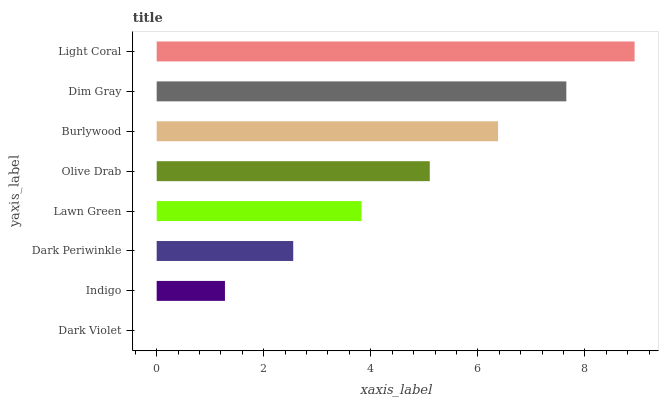Is Dark Violet the minimum?
Answer yes or no. Yes. Is Light Coral the maximum?
Answer yes or no. Yes. Is Indigo the minimum?
Answer yes or no. No. Is Indigo the maximum?
Answer yes or no. No. Is Indigo greater than Dark Violet?
Answer yes or no. Yes. Is Dark Violet less than Indigo?
Answer yes or no. Yes. Is Dark Violet greater than Indigo?
Answer yes or no. No. Is Indigo less than Dark Violet?
Answer yes or no. No. Is Olive Drab the high median?
Answer yes or no. Yes. Is Lawn Green the low median?
Answer yes or no. Yes. Is Burlywood the high median?
Answer yes or no. No. Is Light Coral the low median?
Answer yes or no. No. 